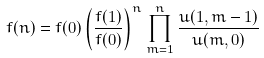Convert formula to latex. <formula><loc_0><loc_0><loc_500><loc_500>f ( n ) = f ( 0 ) \left ( \frac { f ( 1 ) } { f ( 0 ) } \right ) ^ { n } \prod _ { m = 1 } ^ { n } \frac { u ( 1 , m - 1 ) } { u ( m , 0 ) }</formula> 